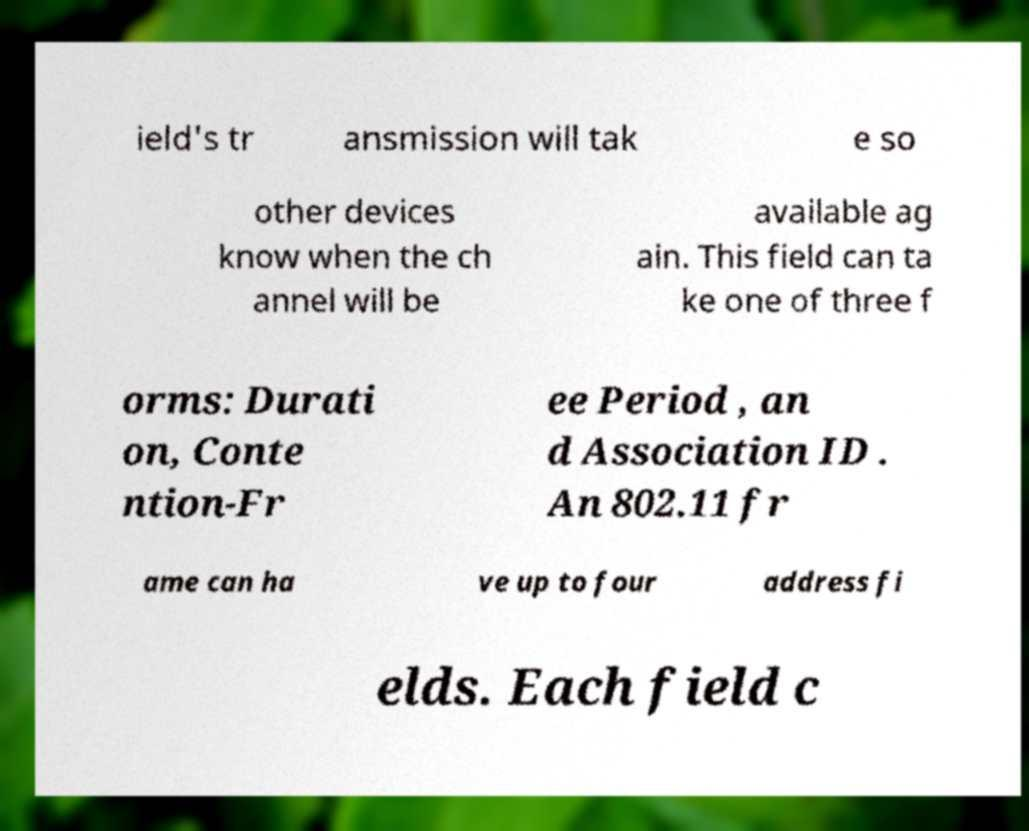Can you read and provide the text displayed in the image?This photo seems to have some interesting text. Can you extract and type it out for me? ield's tr ansmission will tak e so other devices know when the ch annel will be available ag ain. This field can ta ke one of three f orms: Durati on, Conte ntion-Fr ee Period , an d Association ID . An 802.11 fr ame can ha ve up to four address fi elds. Each field c 